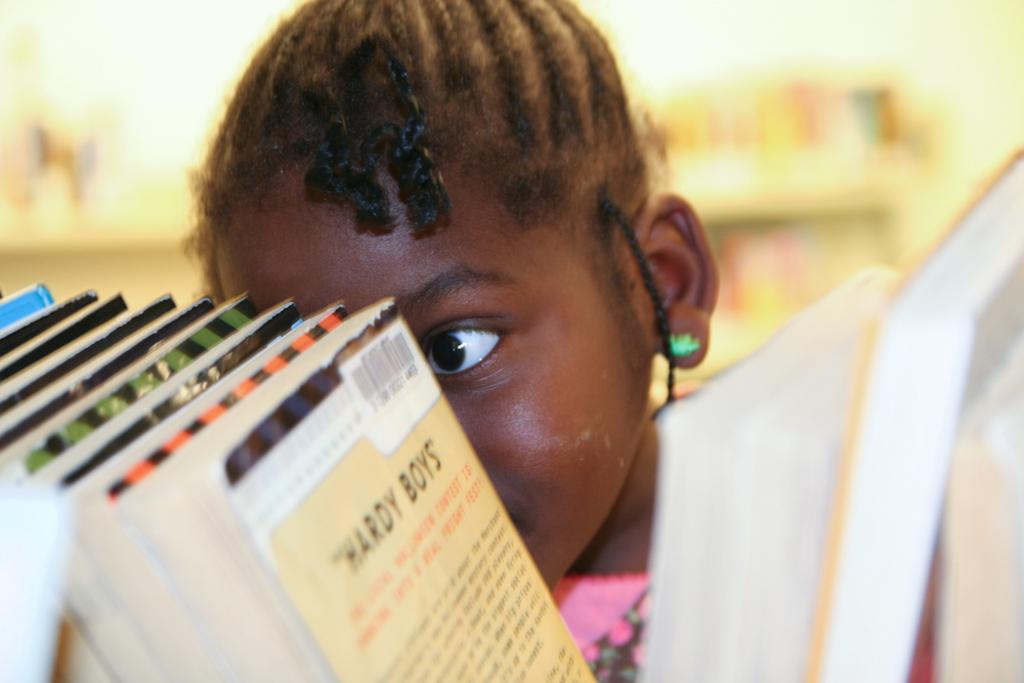What is the main subject of the image? There is a child in the image. What can be seen in the foreground of the image? There are books arranged in order in the image. Can you describe the background of the image? The background of the image is blurry. What type of club does the child belong to in the image? There is no indication in the image that the child belongs to any club. 